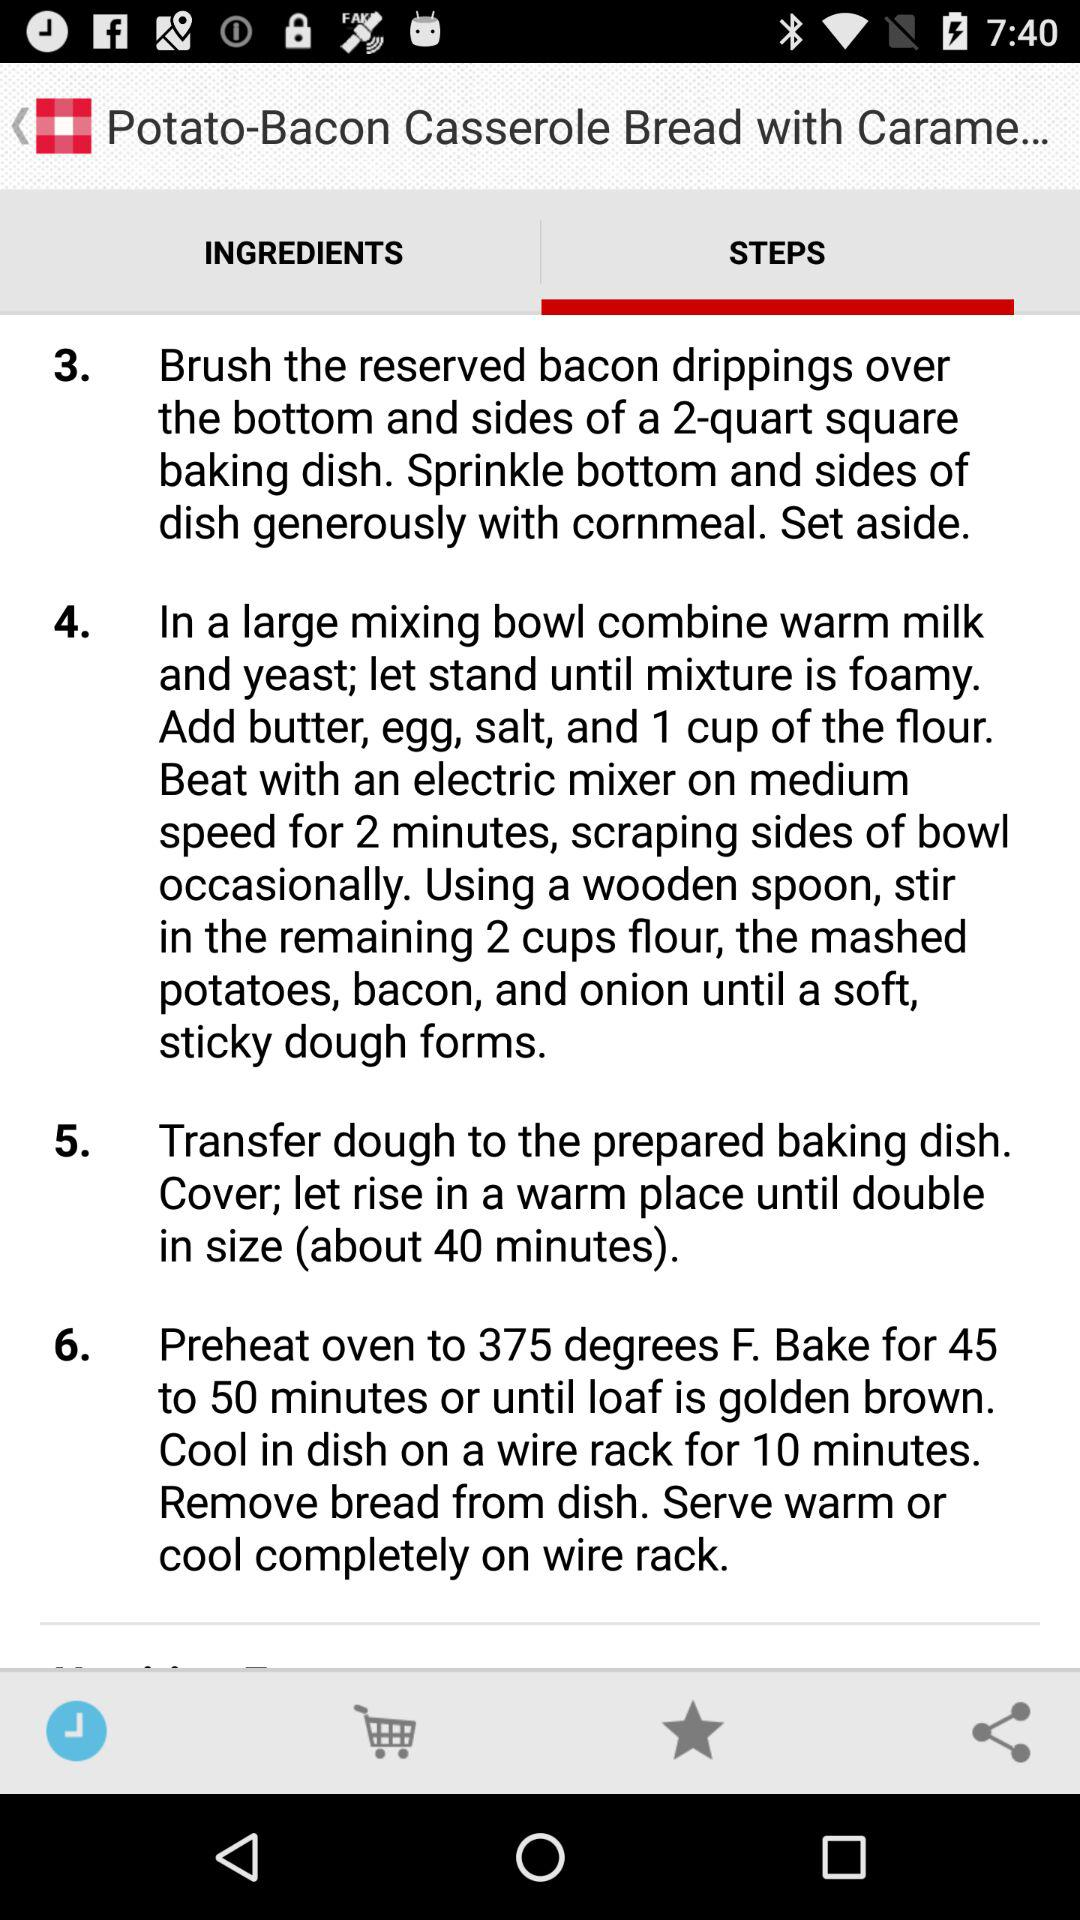What is the baking time of the dish? The baking time of the dish is 45 to 50 minutes. 